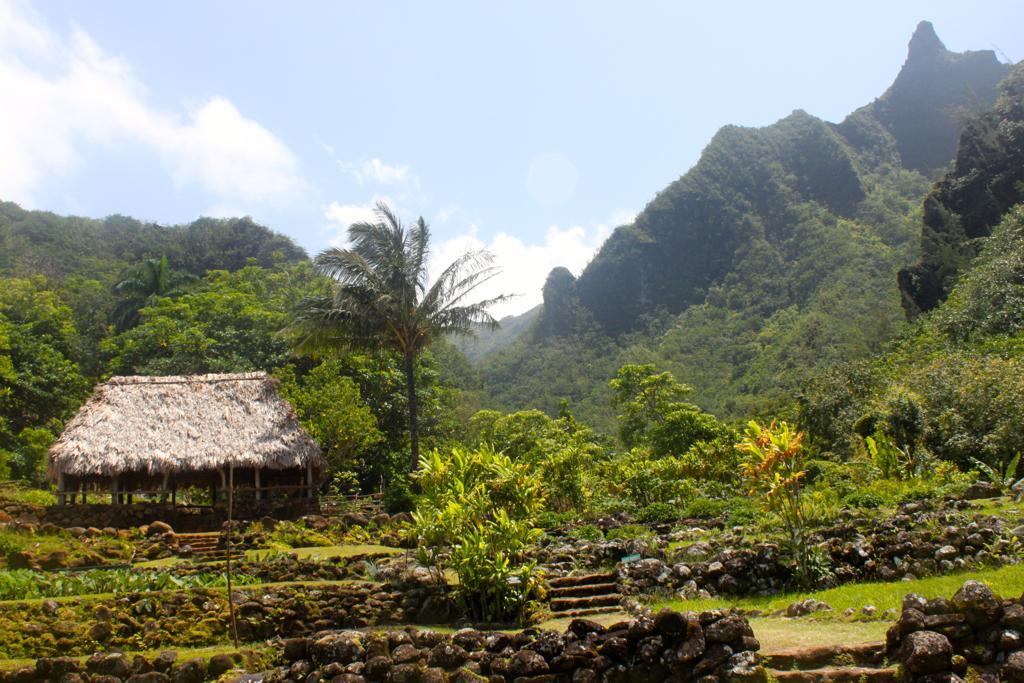How would you summarize this image in a sentence or two? This image is clicked outside. There are so many trees and plants in the middle. There is a hut on the left side. There is sky at the top. 